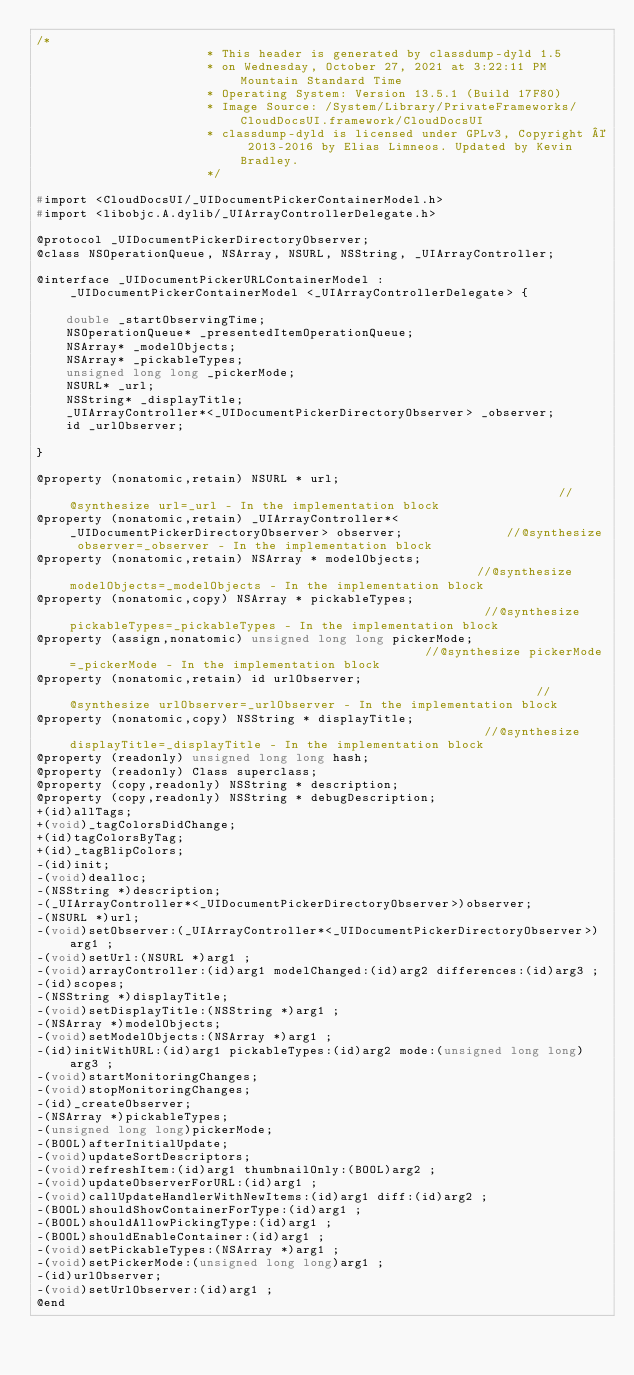Convert code to text. <code><loc_0><loc_0><loc_500><loc_500><_C_>/*
                       * This header is generated by classdump-dyld 1.5
                       * on Wednesday, October 27, 2021 at 3:22:11 PM Mountain Standard Time
                       * Operating System: Version 13.5.1 (Build 17F80)
                       * Image Source: /System/Library/PrivateFrameworks/CloudDocsUI.framework/CloudDocsUI
                       * classdump-dyld is licensed under GPLv3, Copyright © 2013-2016 by Elias Limneos. Updated by Kevin Bradley.
                       */

#import <CloudDocsUI/_UIDocumentPickerContainerModel.h>
#import <libobjc.A.dylib/_UIArrayControllerDelegate.h>

@protocol _UIDocumentPickerDirectoryObserver;
@class NSOperationQueue, NSArray, NSURL, NSString, _UIArrayController;

@interface _UIDocumentPickerURLContainerModel : _UIDocumentPickerContainerModel <_UIArrayControllerDelegate> {

	double _startObservingTime;
	NSOperationQueue* _presentedItemOperationQueue;
	NSArray* _modelObjects;
	NSArray* _pickableTypes;
	unsigned long long _pickerMode;
	NSURL* _url;
	NSString* _displayTitle;
	_UIArrayController*<_UIDocumentPickerDirectoryObserver> _observer;
	id _urlObserver;

}

@property (nonatomic,retain) NSURL * url;                                                                   //@synthesize url=_url - In the implementation block
@property (nonatomic,retain) _UIArrayController*<_UIDocumentPickerDirectoryObserver> observer;              //@synthesize observer=_observer - In the implementation block
@property (nonatomic,retain) NSArray * modelObjects;                                                        //@synthesize modelObjects=_modelObjects - In the implementation block
@property (nonatomic,copy) NSArray * pickableTypes;                                                         //@synthesize pickableTypes=_pickableTypes - In the implementation block
@property (assign,nonatomic) unsigned long long pickerMode;                                                 //@synthesize pickerMode=_pickerMode - In the implementation block
@property (nonatomic,retain) id urlObserver;                                                                //@synthesize urlObserver=_urlObserver - In the implementation block
@property (nonatomic,copy) NSString * displayTitle;                                                         //@synthesize displayTitle=_displayTitle - In the implementation block
@property (readonly) unsigned long long hash; 
@property (readonly) Class superclass; 
@property (copy,readonly) NSString * description; 
@property (copy,readonly) NSString * debugDescription; 
+(id)allTags;
+(void)_tagColorsDidChange;
+(id)tagColorsByTag;
+(id)_tagBlipColors;
-(id)init;
-(void)dealloc;
-(NSString *)description;
-(_UIArrayController*<_UIDocumentPickerDirectoryObserver>)observer;
-(NSURL *)url;
-(void)setObserver:(_UIArrayController*<_UIDocumentPickerDirectoryObserver>)arg1 ;
-(void)setUrl:(NSURL *)arg1 ;
-(void)arrayController:(id)arg1 modelChanged:(id)arg2 differences:(id)arg3 ;
-(id)scopes;
-(NSString *)displayTitle;
-(void)setDisplayTitle:(NSString *)arg1 ;
-(NSArray *)modelObjects;
-(void)setModelObjects:(NSArray *)arg1 ;
-(id)initWithURL:(id)arg1 pickableTypes:(id)arg2 mode:(unsigned long long)arg3 ;
-(void)startMonitoringChanges;
-(void)stopMonitoringChanges;
-(id)_createObserver;
-(NSArray *)pickableTypes;
-(unsigned long long)pickerMode;
-(BOOL)afterInitialUpdate;
-(void)updateSortDescriptors;
-(void)refreshItem:(id)arg1 thumbnailOnly:(BOOL)arg2 ;
-(void)updateObserverForURL:(id)arg1 ;
-(void)callUpdateHandlerWithNewItems:(id)arg1 diff:(id)arg2 ;
-(BOOL)shouldShowContainerForType:(id)arg1 ;
-(BOOL)shouldAllowPickingType:(id)arg1 ;
-(BOOL)shouldEnableContainer:(id)arg1 ;
-(void)setPickableTypes:(NSArray *)arg1 ;
-(void)setPickerMode:(unsigned long long)arg1 ;
-(id)urlObserver;
-(void)setUrlObserver:(id)arg1 ;
@end

</code> 